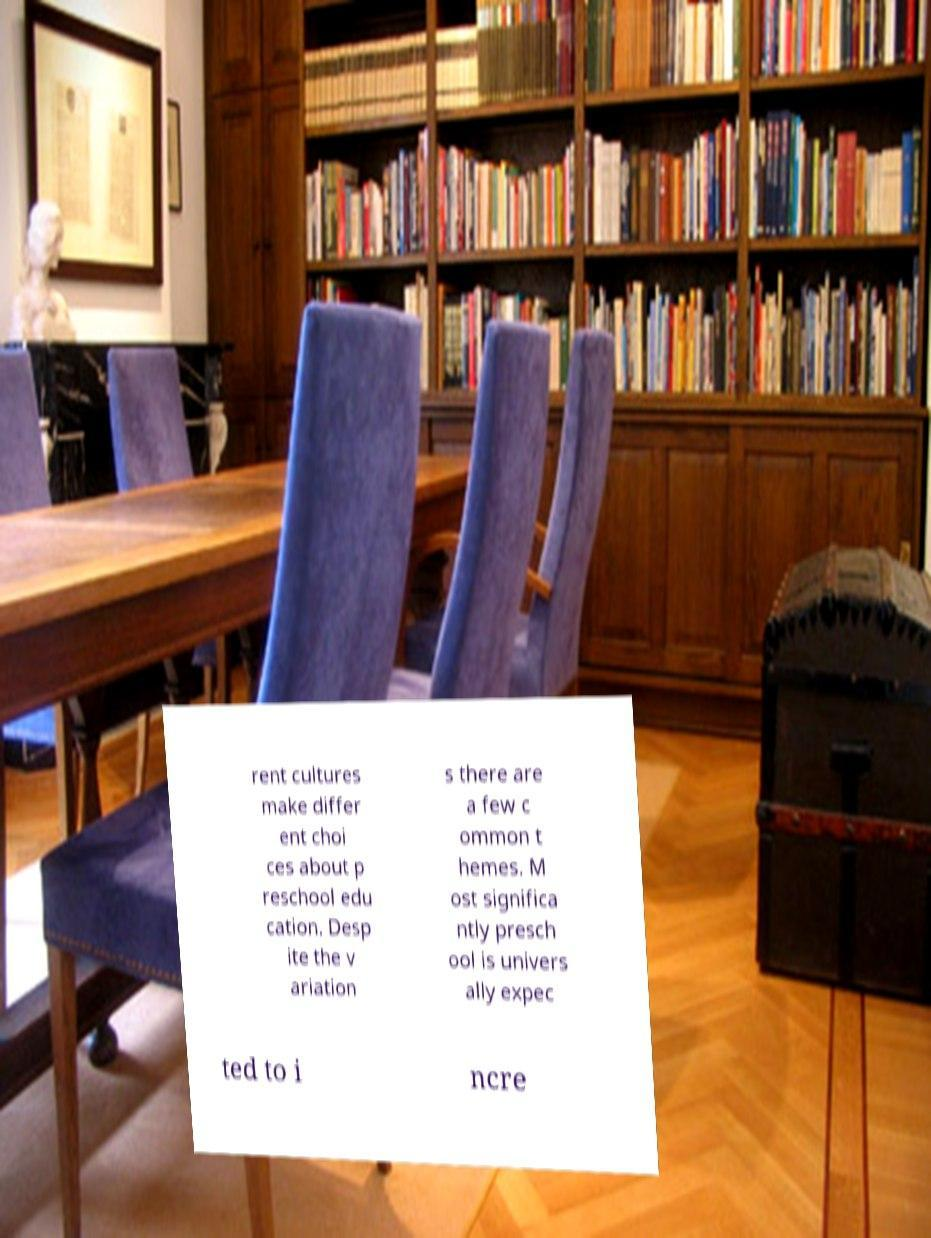Could you assist in decoding the text presented in this image and type it out clearly? rent cultures make differ ent choi ces about p reschool edu cation. Desp ite the v ariation s there are a few c ommon t hemes. M ost significa ntly presch ool is univers ally expec ted to i ncre 